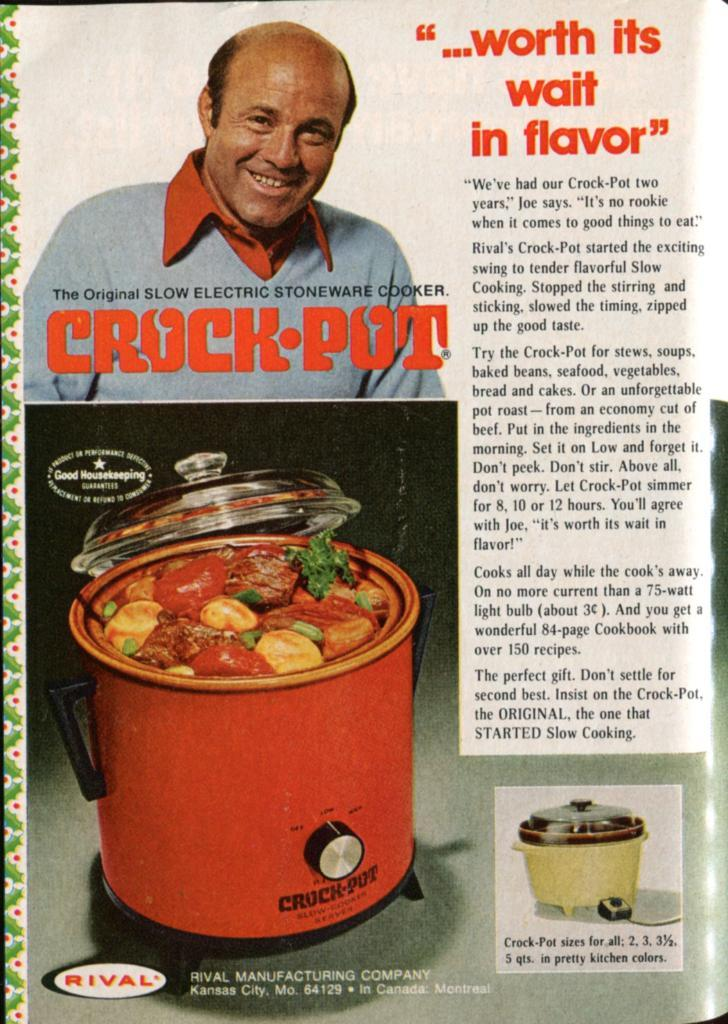<image>
Relay a brief, clear account of the picture shown. Magazine page that says the word "RIVAL" on the bottom. 